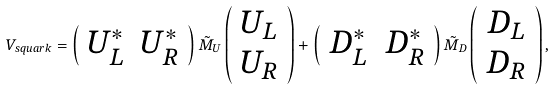<formula> <loc_0><loc_0><loc_500><loc_500>V _ { s q u a r k } = \left ( \begin{array} { c c } U _ { L } ^ { * } & U _ { R } ^ { * } \end{array} \right ) \tilde { M } _ { U } \left ( \begin{array} { c } U _ { L } \\ U _ { R } \end{array} \right ) + \left ( \begin{array} { c c } D _ { L } ^ { * } & D _ { R } ^ { * } \end{array} \right ) \tilde { M } _ { D } \left ( \begin{array} { c } D _ { L } \\ D _ { R } \end{array} \right ) ,</formula> 